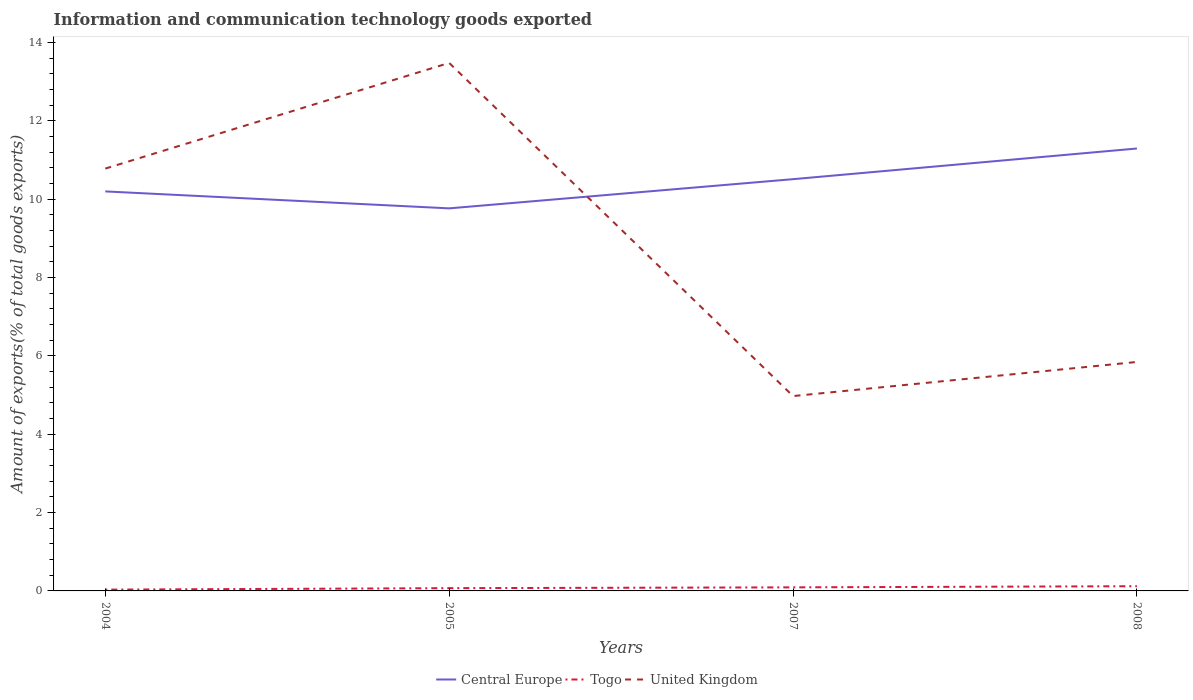How many different coloured lines are there?
Keep it short and to the point. 3. Does the line corresponding to Central Europe intersect with the line corresponding to United Kingdom?
Your answer should be very brief. Yes. Is the number of lines equal to the number of legend labels?
Provide a short and direct response. Yes. Across all years, what is the maximum amount of goods exported in Togo?
Offer a very short reply. 0.03. In which year was the amount of goods exported in Central Europe maximum?
Offer a very short reply. 2005. What is the total amount of goods exported in United Kingdom in the graph?
Your response must be concise. 4.93. What is the difference between the highest and the second highest amount of goods exported in Central Europe?
Ensure brevity in your answer.  1.53. What is the difference between the highest and the lowest amount of goods exported in Central Europe?
Provide a succinct answer. 2. How many lines are there?
Provide a short and direct response. 3. Are the values on the major ticks of Y-axis written in scientific E-notation?
Offer a very short reply. No. Does the graph contain any zero values?
Your answer should be compact. No. How many legend labels are there?
Provide a succinct answer. 3. How are the legend labels stacked?
Your response must be concise. Horizontal. What is the title of the graph?
Give a very brief answer. Information and communication technology goods exported. Does "Georgia" appear as one of the legend labels in the graph?
Give a very brief answer. No. What is the label or title of the Y-axis?
Your response must be concise. Amount of exports(% of total goods exports). What is the Amount of exports(% of total goods exports) in Central Europe in 2004?
Offer a terse response. 10.2. What is the Amount of exports(% of total goods exports) of Togo in 2004?
Provide a short and direct response. 0.03. What is the Amount of exports(% of total goods exports) in United Kingdom in 2004?
Provide a succinct answer. 10.78. What is the Amount of exports(% of total goods exports) in Central Europe in 2005?
Provide a short and direct response. 9.76. What is the Amount of exports(% of total goods exports) of Togo in 2005?
Provide a succinct answer. 0.07. What is the Amount of exports(% of total goods exports) in United Kingdom in 2005?
Your answer should be compact. 13.48. What is the Amount of exports(% of total goods exports) in Central Europe in 2007?
Your response must be concise. 10.51. What is the Amount of exports(% of total goods exports) in Togo in 2007?
Offer a very short reply. 0.09. What is the Amount of exports(% of total goods exports) of United Kingdom in 2007?
Your answer should be very brief. 4.97. What is the Amount of exports(% of total goods exports) of Central Europe in 2008?
Provide a short and direct response. 11.29. What is the Amount of exports(% of total goods exports) in Togo in 2008?
Provide a short and direct response. 0.12. What is the Amount of exports(% of total goods exports) in United Kingdom in 2008?
Provide a short and direct response. 5.84. Across all years, what is the maximum Amount of exports(% of total goods exports) of Central Europe?
Provide a succinct answer. 11.29. Across all years, what is the maximum Amount of exports(% of total goods exports) in Togo?
Offer a very short reply. 0.12. Across all years, what is the maximum Amount of exports(% of total goods exports) of United Kingdom?
Ensure brevity in your answer.  13.48. Across all years, what is the minimum Amount of exports(% of total goods exports) of Central Europe?
Provide a succinct answer. 9.76. Across all years, what is the minimum Amount of exports(% of total goods exports) in Togo?
Ensure brevity in your answer.  0.03. Across all years, what is the minimum Amount of exports(% of total goods exports) of United Kingdom?
Offer a very short reply. 4.97. What is the total Amount of exports(% of total goods exports) in Central Europe in the graph?
Make the answer very short. 41.76. What is the total Amount of exports(% of total goods exports) in Togo in the graph?
Make the answer very short. 0.31. What is the total Amount of exports(% of total goods exports) in United Kingdom in the graph?
Your answer should be very brief. 35.07. What is the difference between the Amount of exports(% of total goods exports) of Central Europe in 2004 and that in 2005?
Provide a short and direct response. 0.43. What is the difference between the Amount of exports(% of total goods exports) in Togo in 2004 and that in 2005?
Ensure brevity in your answer.  -0.04. What is the difference between the Amount of exports(% of total goods exports) of United Kingdom in 2004 and that in 2005?
Your answer should be very brief. -2.7. What is the difference between the Amount of exports(% of total goods exports) of Central Europe in 2004 and that in 2007?
Your response must be concise. -0.31. What is the difference between the Amount of exports(% of total goods exports) in Togo in 2004 and that in 2007?
Your answer should be compact. -0.06. What is the difference between the Amount of exports(% of total goods exports) of United Kingdom in 2004 and that in 2007?
Your response must be concise. 5.81. What is the difference between the Amount of exports(% of total goods exports) of Central Europe in 2004 and that in 2008?
Ensure brevity in your answer.  -1.09. What is the difference between the Amount of exports(% of total goods exports) of Togo in 2004 and that in 2008?
Keep it short and to the point. -0.09. What is the difference between the Amount of exports(% of total goods exports) in United Kingdom in 2004 and that in 2008?
Provide a short and direct response. 4.93. What is the difference between the Amount of exports(% of total goods exports) in Central Europe in 2005 and that in 2007?
Your answer should be compact. -0.74. What is the difference between the Amount of exports(% of total goods exports) of Togo in 2005 and that in 2007?
Offer a terse response. -0.02. What is the difference between the Amount of exports(% of total goods exports) in United Kingdom in 2005 and that in 2007?
Give a very brief answer. 8.5. What is the difference between the Amount of exports(% of total goods exports) in Central Europe in 2005 and that in 2008?
Provide a succinct answer. -1.53. What is the difference between the Amount of exports(% of total goods exports) of Togo in 2005 and that in 2008?
Offer a very short reply. -0.05. What is the difference between the Amount of exports(% of total goods exports) in United Kingdom in 2005 and that in 2008?
Provide a succinct answer. 7.63. What is the difference between the Amount of exports(% of total goods exports) of Central Europe in 2007 and that in 2008?
Ensure brevity in your answer.  -0.78. What is the difference between the Amount of exports(% of total goods exports) of Togo in 2007 and that in 2008?
Give a very brief answer. -0.03. What is the difference between the Amount of exports(% of total goods exports) of United Kingdom in 2007 and that in 2008?
Offer a very short reply. -0.87. What is the difference between the Amount of exports(% of total goods exports) of Central Europe in 2004 and the Amount of exports(% of total goods exports) of Togo in 2005?
Your answer should be compact. 10.13. What is the difference between the Amount of exports(% of total goods exports) in Central Europe in 2004 and the Amount of exports(% of total goods exports) in United Kingdom in 2005?
Offer a terse response. -3.28. What is the difference between the Amount of exports(% of total goods exports) of Togo in 2004 and the Amount of exports(% of total goods exports) of United Kingdom in 2005?
Your answer should be very brief. -13.44. What is the difference between the Amount of exports(% of total goods exports) in Central Europe in 2004 and the Amount of exports(% of total goods exports) in Togo in 2007?
Offer a very short reply. 10.1. What is the difference between the Amount of exports(% of total goods exports) in Central Europe in 2004 and the Amount of exports(% of total goods exports) in United Kingdom in 2007?
Ensure brevity in your answer.  5.22. What is the difference between the Amount of exports(% of total goods exports) in Togo in 2004 and the Amount of exports(% of total goods exports) in United Kingdom in 2007?
Provide a succinct answer. -4.94. What is the difference between the Amount of exports(% of total goods exports) in Central Europe in 2004 and the Amount of exports(% of total goods exports) in Togo in 2008?
Your response must be concise. 10.08. What is the difference between the Amount of exports(% of total goods exports) in Central Europe in 2004 and the Amount of exports(% of total goods exports) in United Kingdom in 2008?
Keep it short and to the point. 4.35. What is the difference between the Amount of exports(% of total goods exports) of Togo in 2004 and the Amount of exports(% of total goods exports) of United Kingdom in 2008?
Your response must be concise. -5.81. What is the difference between the Amount of exports(% of total goods exports) in Central Europe in 2005 and the Amount of exports(% of total goods exports) in Togo in 2007?
Offer a terse response. 9.67. What is the difference between the Amount of exports(% of total goods exports) of Central Europe in 2005 and the Amount of exports(% of total goods exports) of United Kingdom in 2007?
Make the answer very short. 4.79. What is the difference between the Amount of exports(% of total goods exports) of Togo in 2005 and the Amount of exports(% of total goods exports) of United Kingdom in 2007?
Offer a very short reply. -4.9. What is the difference between the Amount of exports(% of total goods exports) in Central Europe in 2005 and the Amount of exports(% of total goods exports) in Togo in 2008?
Make the answer very short. 9.64. What is the difference between the Amount of exports(% of total goods exports) of Central Europe in 2005 and the Amount of exports(% of total goods exports) of United Kingdom in 2008?
Your response must be concise. 3.92. What is the difference between the Amount of exports(% of total goods exports) of Togo in 2005 and the Amount of exports(% of total goods exports) of United Kingdom in 2008?
Ensure brevity in your answer.  -5.77. What is the difference between the Amount of exports(% of total goods exports) in Central Europe in 2007 and the Amount of exports(% of total goods exports) in Togo in 2008?
Offer a very short reply. 10.39. What is the difference between the Amount of exports(% of total goods exports) in Central Europe in 2007 and the Amount of exports(% of total goods exports) in United Kingdom in 2008?
Offer a very short reply. 4.66. What is the difference between the Amount of exports(% of total goods exports) in Togo in 2007 and the Amount of exports(% of total goods exports) in United Kingdom in 2008?
Your answer should be very brief. -5.75. What is the average Amount of exports(% of total goods exports) of Central Europe per year?
Your answer should be compact. 10.44. What is the average Amount of exports(% of total goods exports) in Togo per year?
Your response must be concise. 0.08. What is the average Amount of exports(% of total goods exports) of United Kingdom per year?
Provide a succinct answer. 8.77. In the year 2004, what is the difference between the Amount of exports(% of total goods exports) of Central Europe and Amount of exports(% of total goods exports) of Togo?
Provide a short and direct response. 10.16. In the year 2004, what is the difference between the Amount of exports(% of total goods exports) in Central Europe and Amount of exports(% of total goods exports) in United Kingdom?
Offer a terse response. -0.58. In the year 2004, what is the difference between the Amount of exports(% of total goods exports) in Togo and Amount of exports(% of total goods exports) in United Kingdom?
Provide a short and direct response. -10.74. In the year 2005, what is the difference between the Amount of exports(% of total goods exports) in Central Europe and Amount of exports(% of total goods exports) in Togo?
Offer a very short reply. 9.69. In the year 2005, what is the difference between the Amount of exports(% of total goods exports) of Central Europe and Amount of exports(% of total goods exports) of United Kingdom?
Provide a succinct answer. -3.71. In the year 2005, what is the difference between the Amount of exports(% of total goods exports) in Togo and Amount of exports(% of total goods exports) in United Kingdom?
Provide a short and direct response. -13.4. In the year 2007, what is the difference between the Amount of exports(% of total goods exports) in Central Europe and Amount of exports(% of total goods exports) in Togo?
Your response must be concise. 10.42. In the year 2007, what is the difference between the Amount of exports(% of total goods exports) in Central Europe and Amount of exports(% of total goods exports) in United Kingdom?
Give a very brief answer. 5.54. In the year 2007, what is the difference between the Amount of exports(% of total goods exports) in Togo and Amount of exports(% of total goods exports) in United Kingdom?
Your response must be concise. -4.88. In the year 2008, what is the difference between the Amount of exports(% of total goods exports) of Central Europe and Amount of exports(% of total goods exports) of Togo?
Provide a succinct answer. 11.17. In the year 2008, what is the difference between the Amount of exports(% of total goods exports) in Central Europe and Amount of exports(% of total goods exports) in United Kingdom?
Make the answer very short. 5.45. In the year 2008, what is the difference between the Amount of exports(% of total goods exports) in Togo and Amount of exports(% of total goods exports) in United Kingdom?
Offer a terse response. -5.72. What is the ratio of the Amount of exports(% of total goods exports) in Central Europe in 2004 to that in 2005?
Ensure brevity in your answer.  1.04. What is the ratio of the Amount of exports(% of total goods exports) of Togo in 2004 to that in 2005?
Provide a short and direct response. 0.47. What is the ratio of the Amount of exports(% of total goods exports) of United Kingdom in 2004 to that in 2005?
Keep it short and to the point. 0.8. What is the ratio of the Amount of exports(% of total goods exports) in Central Europe in 2004 to that in 2007?
Your answer should be very brief. 0.97. What is the ratio of the Amount of exports(% of total goods exports) in Togo in 2004 to that in 2007?
Give a very brief answer. 0.36. What is the ratio of the Amount of exports(% of total goods exports) of United Kingdom in 2004 to that in 2007?
Provide a short and direct response. 2.17. What is the ratio of the Amount of exports(% of total goods exports) in Central Europe in 2004 to that in 2008?
Keep it short and to the point. 0.9. What is the ratio of the Amount of exports(% of total goods exports) of Togo in 2004 to that in 2008?
Your answer should be compact. 0.28. What is the ratio of the Amount of exports(% of total goods exports) of United Kingdom in 2004 to that in 2008?
Keep it short and to the point. 1.84. What is the ratio of the Amount of exports(% of total goods exports) in Central Europe in 2005 to that in 2007?
Provide a short and direct response. 0.93. What is the ratio of the Amount of exports(% of total goods exports) of Togo in 2005 to that in 2007?
Make the answer very short. 0.78. What is the ratio of the Amount of exports(% of total goods exports) in United Kingdom in 2005 to that in 2007?
Your response must be concise. 2.71. What is the ratio of the Amount of exports(% of total goods exports) of Central Europe in 2005 to that in 2008?
Your response must be concise. 0.86. What is the ratio of the Amount of exports(% of total goods exports) of Togo in 2005 to that in 2008?
Your response must be concise. 0.59. What is the ratio of the Amount of exports(% of total goods exports) in United Kingdom in 2005 to that in 2008?
Offer a very short reply. 2.31. What is the ratio of the Amount of exports(% of total goods exports) of Central Europe in 2007 to that in 2008?
Ensure brevity in your answer.  0.93. What is the ratio of the Amount of exports(% of total goods exports) of Togo in 2007 to that in 2008?
Offer a very short reply. 0.76. What is the ratio of the Amount of exports(% of total goods exports) in United Kingdom in 2007 to that in 2008?
Give a very brief answer. 0.85. What is the difference between the highest and the second highest Amount of exports(% of total goods exports) of Central Europe?
Offer a very short reply. 0.78. What is the difference between the highest and the second highest Amount of exports(% of total goods exports) in Togo?
Keep it short and to the point. 0.03. What is the difference between the highest and the second highest Amount of exports(% of total goods exports) of United Kingdom?
Keep it short and to the point. 2.7. What is the difference between the highest and the lowest Amount of exports(% of total goods exports) of Central Europe?
Keep it short and to the point. 1.53. What is the difference between the highest and the lowest Amount of exports(% of total goods exports) of Togo?
Offer a very short reply. 0.09. What is the difference between the highest and the lowest Amount of exports(% of total goods exports) in United Kingdom?
Make the answer very short. 8.5. 